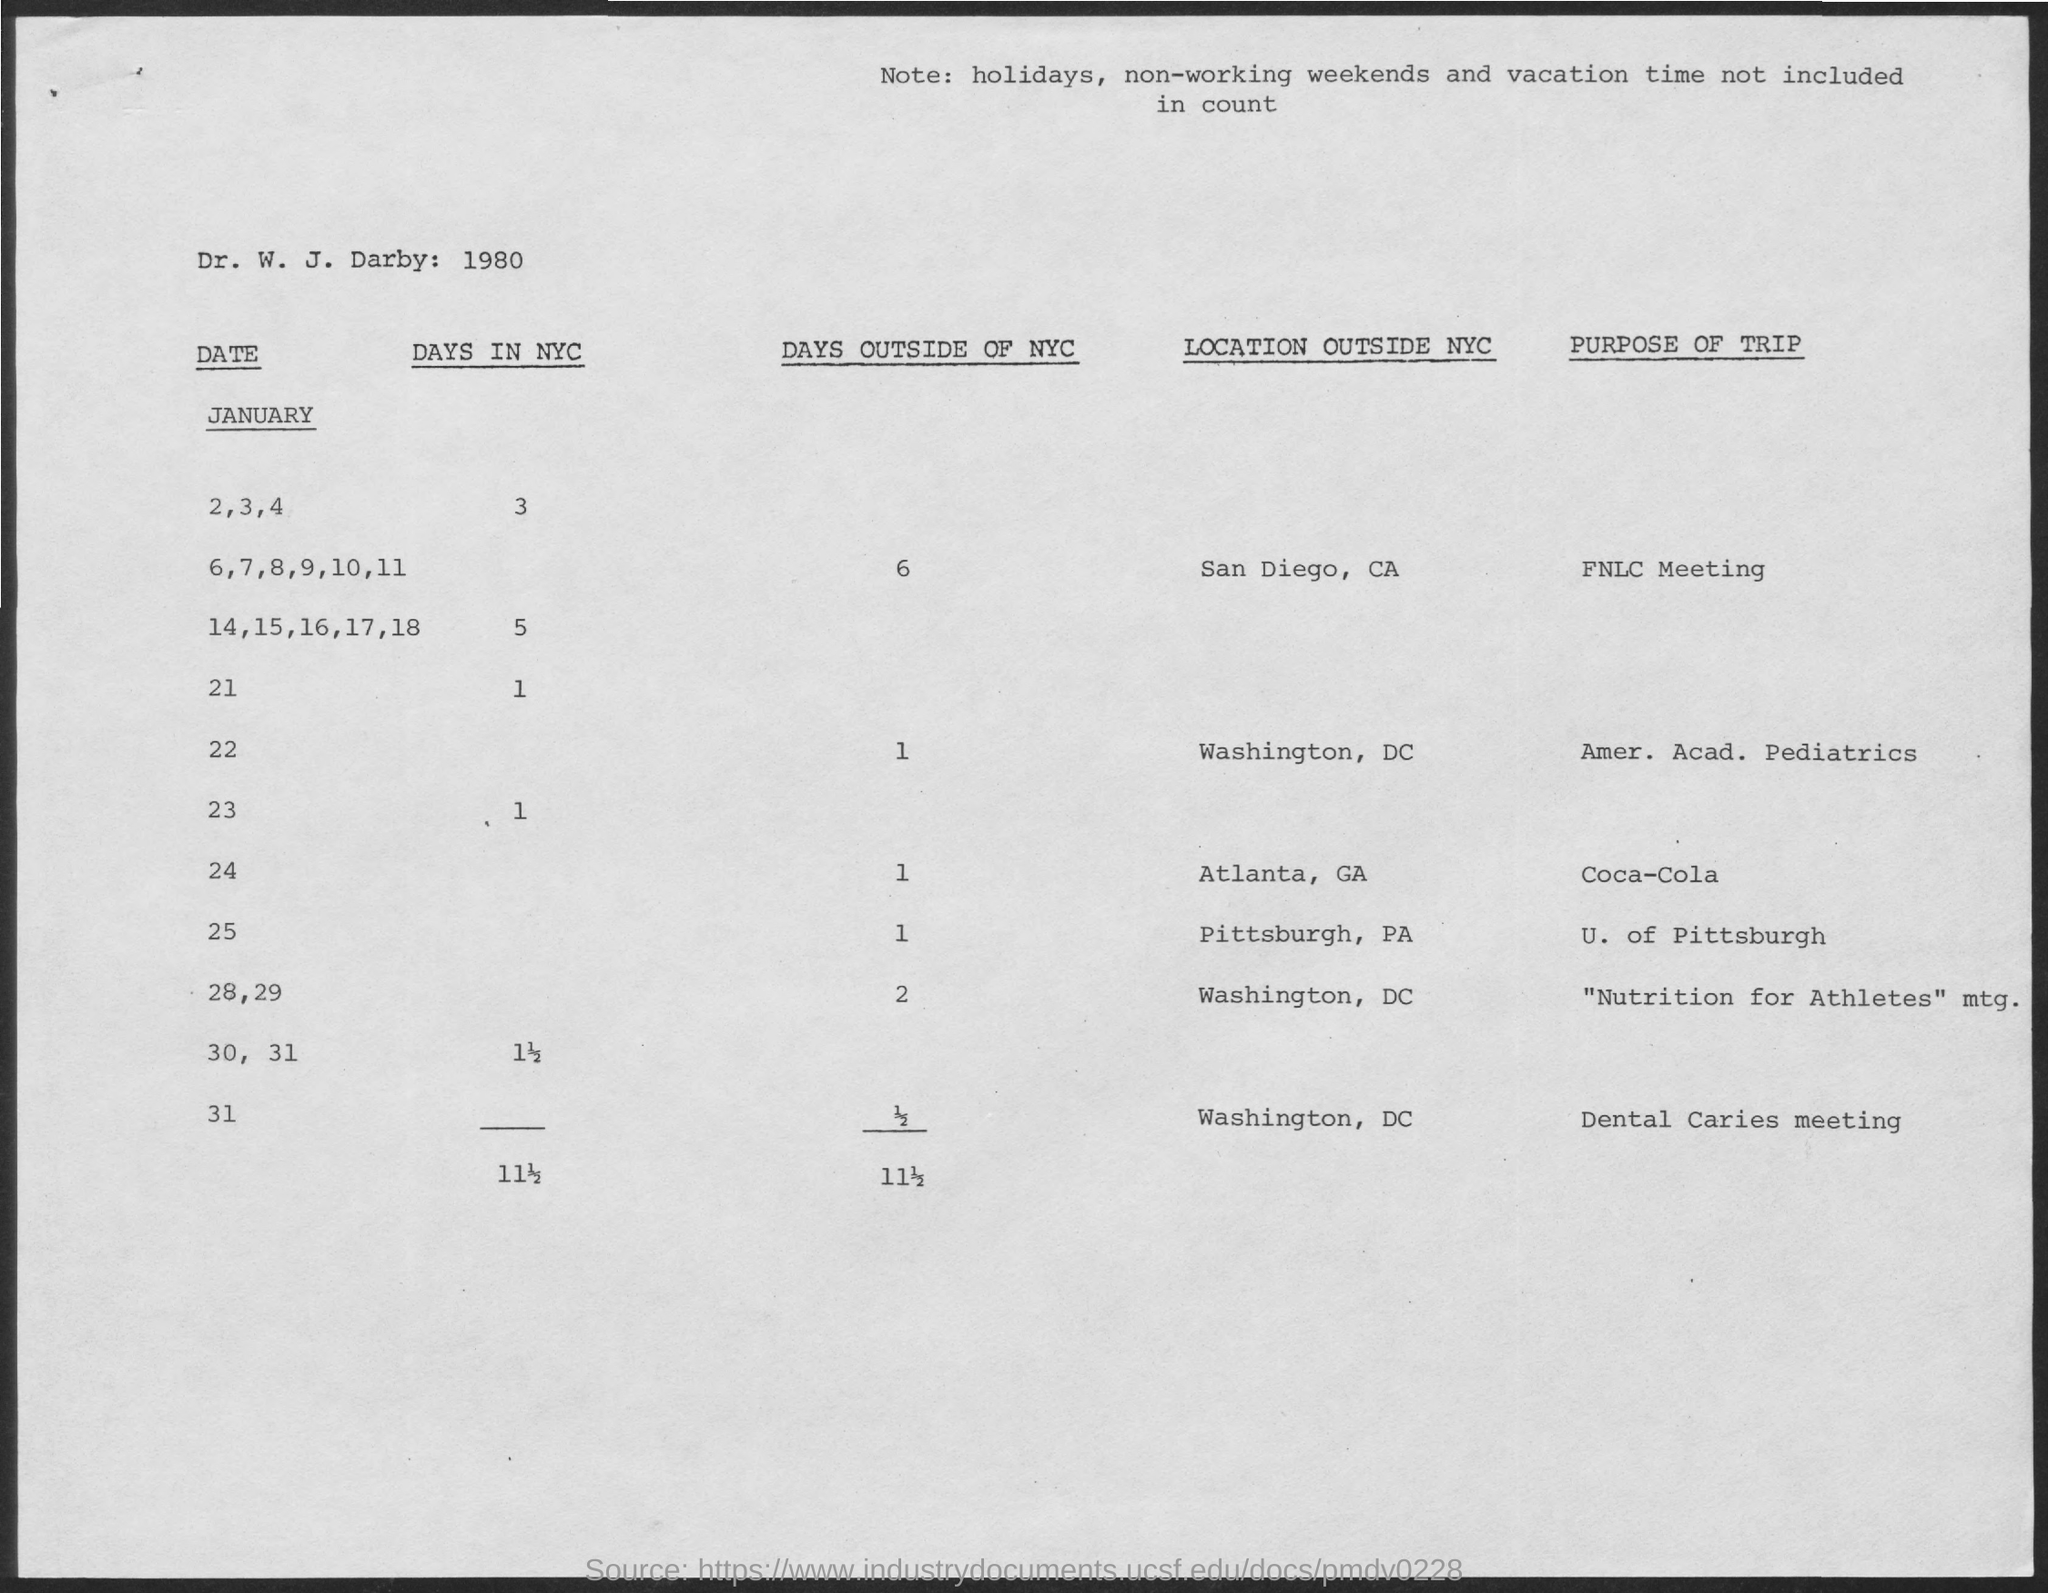What is the purpose of trip on January 24?
Keep it short and to the point. Coca-cola. 